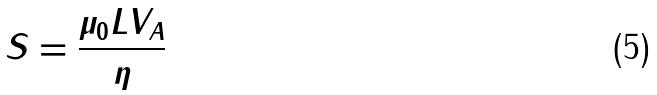<formula> <loc_0><loc_0><loc_500><loc_500>S = \frac { \mu _ { 0 } L V _ { A } } { \eta }</formula> 